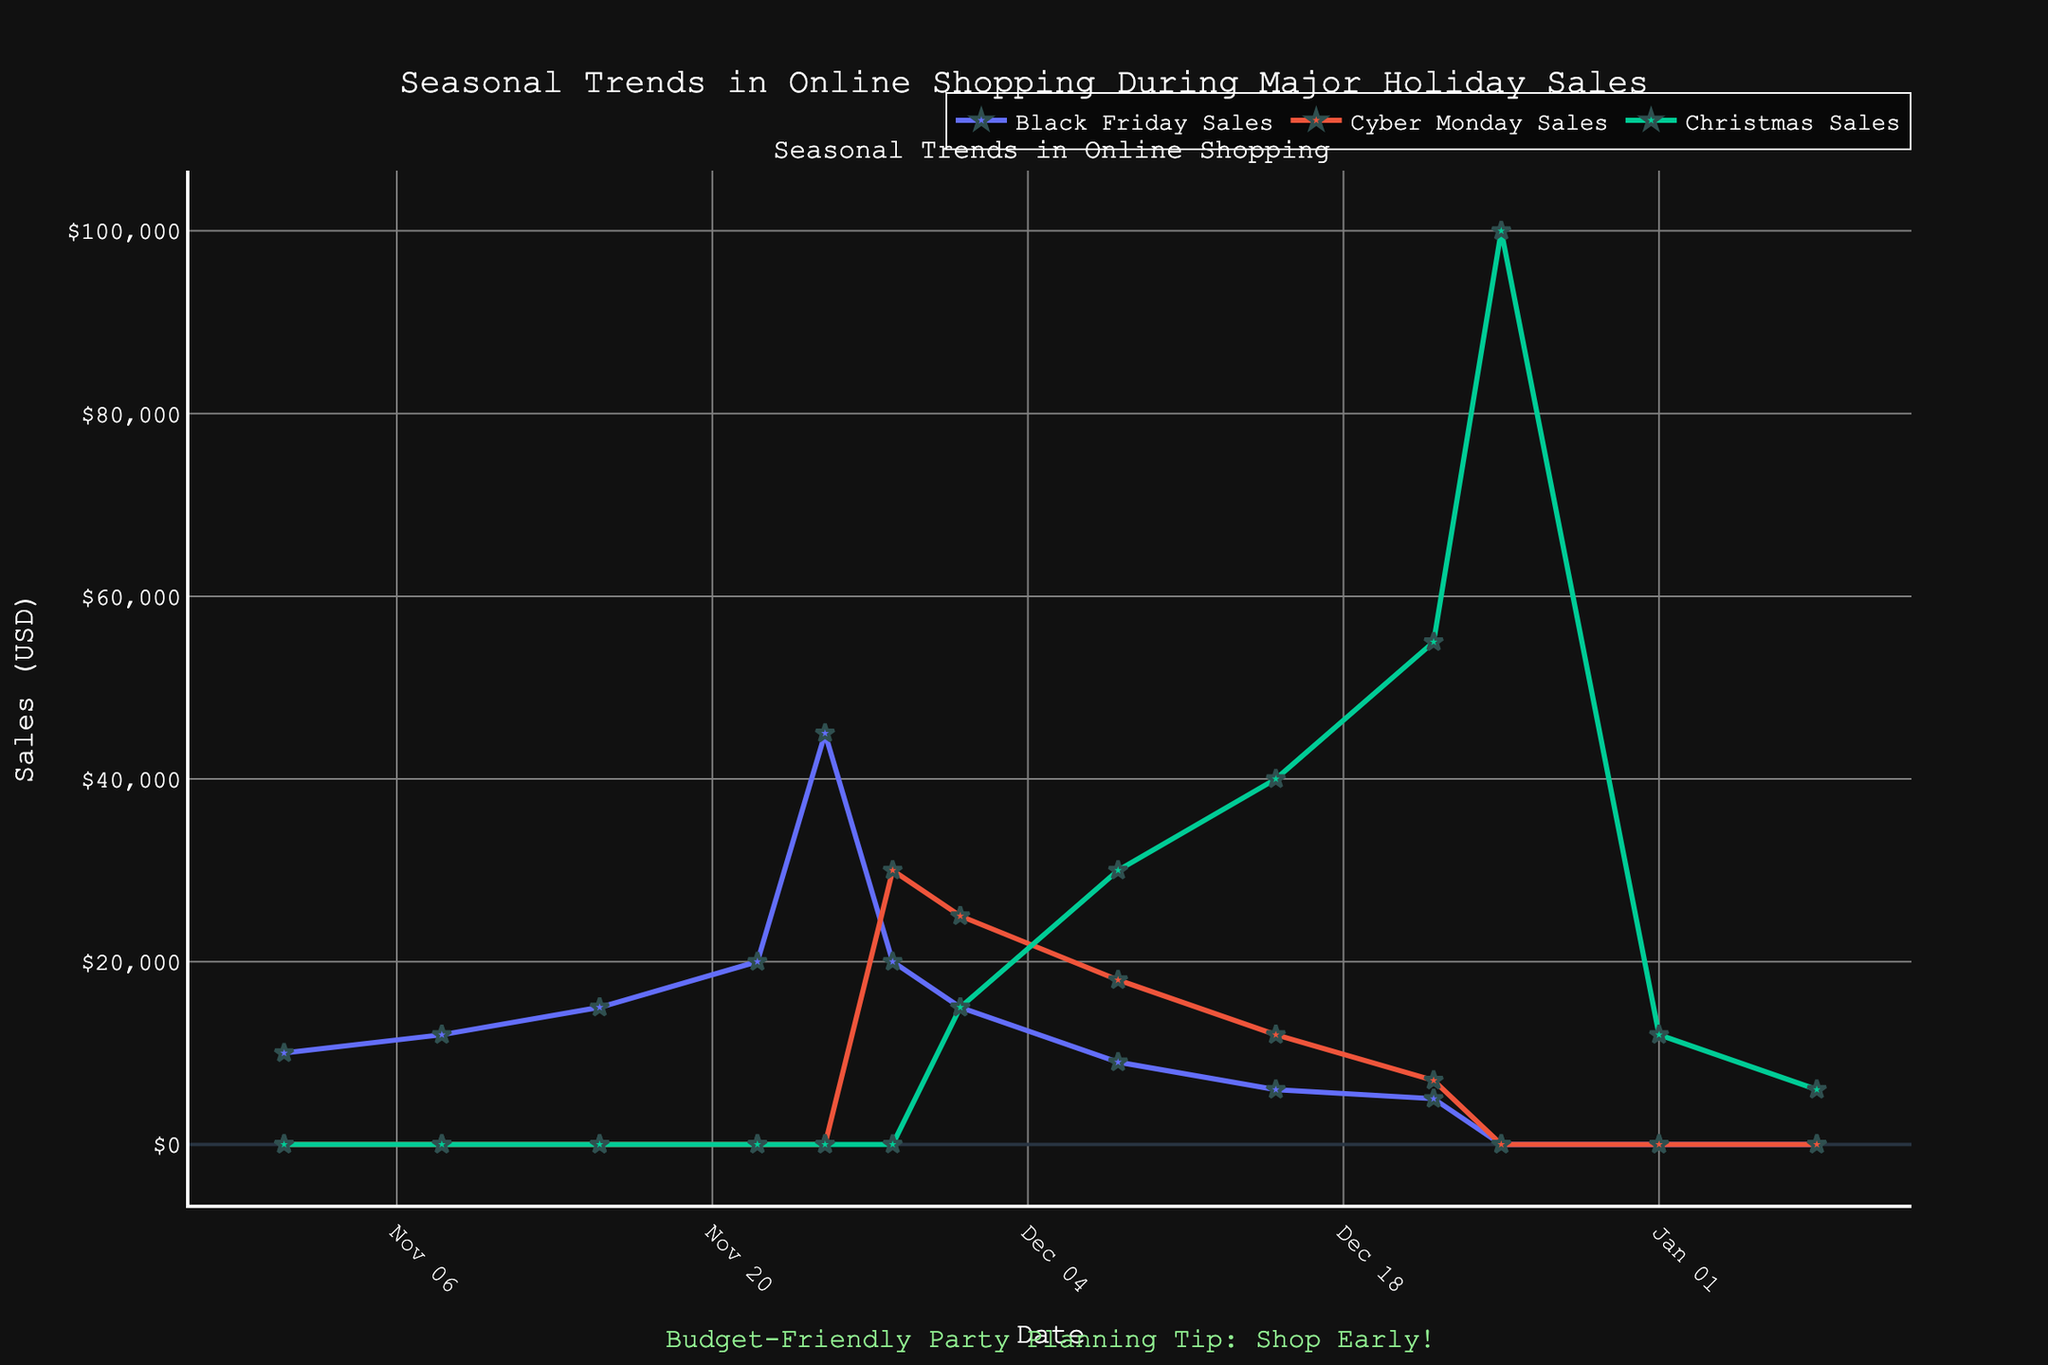What is the title of the plot? The plot title is positioned at the top of the figure and generally gives an overview of what the figure represents.
Answer: Seasonal Trends in Online Shopping During Major Holiday Sales What are the names of the three types of sales tracked in the plot? The labels for each series are indicated in the legend indicating different sales events.
Answer: Black Friday Sales, Cyber Monday Sales, Christmas Sales On which date does Black Friday Sales peak? From the plot, observe when the Black Friday Sales line reaches its highest point.
Answer: 2022-11-25 Which type of sale has the highest peak value in December? Look at the highest points of each sales type in December and compare them.
Answer: Christmas Sales How do Cyber Monday Sales change from November 28th to December 1st? Observe the Cyber Monday Sales line between these two dates to see the trend.
Answer: It decreases from 30000 to 25000 What is the total sales on Cyber Monday? The Cyber Monday sales on November 28th can be read directly from the figure.
Answer: 30000 Compare the sales on Christmas Day to the day after New Year’s Day for Christmas Sales. Note the sales values for Christmas Sales on December 25th and January 1st and compare them.
Answer: 100000 vs 12000 How do the sales trends of Cyber Monday and Black Friday relate on Cyber Monday? Compare the sales values of both types on November 28th.
Answer: Black Friday Sales are 20000 and Cyber Monday Sales are 30000 What are the sales values for Cyber Monday on December 8th and December 15th, and what's the difference? Read the sales values from the plot for the specified dates and calculate the difference.
Answer: December 8th: 18000, December 15th: 12000, Difference: 6000 What is the average Black Friday Sales value during November? Add up all the Black Friday Sales values in November and divide by the number of weeks.
Answer: (10000 + 12000 + 15000 + 20000 + 45000) / 5 = 20400 Which sales type shows the most consistent increase throughout December? Observe the trends in the plot for all sales in December and note which one consistently rises.
Answer: Christmas Sales 